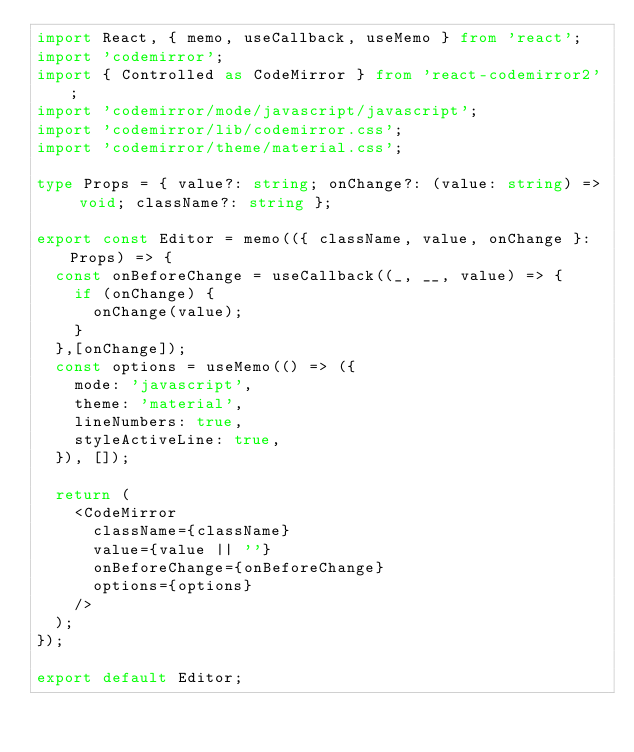<code> <loc_0><loc_0><loc_500><loc_500><_TypeScript_>import React, { memo, useCallback, useMemo } from 'react';
import 'codemirror';
import { Controlled as CodeMirror } from 'react-codemirror2';
import 'codemirror/mode/javascript/javascript';
import 'codemirror/lib/codemirror.css';
import 'codemirror/theme/material.css';

type Props = { value?: string; onChange?: (value: string) => void; className?: string };

export const Editor = memo(({ className, value, onChange }: Props) => {
  const onBeforeChange = useCallback((_, __, value) => {
    if (onChange) {
      onChange(value);
    }
  },[onChange]);
  const options = useMemo(() => ({
    mode: 'javascript',
    theme: 'material',
    lineNumbers: true,
    styleActiveLine: true,
  }), []);

  return (
    <CodeMirror
      className={className}
      value={value || ''}
      onBeforeChange={onBeforeChange}
      options={options}
    />
  );
});

export default Editor;
</code> 